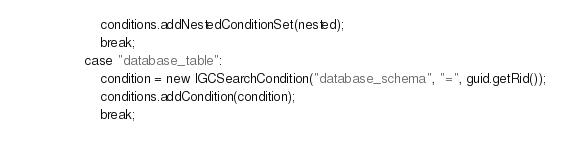Convert code to text. <code><loc_0><loc_0><loc_500><loc_500><_Java_>                    conditions.addNestedConditionSet(nested);
                    break;
                case "database_table":
                    condition = new IGCSearchCondition("database_schema", "=", guid.getRid());
                    conditions.addCondition(condition);
                    break;</code> 